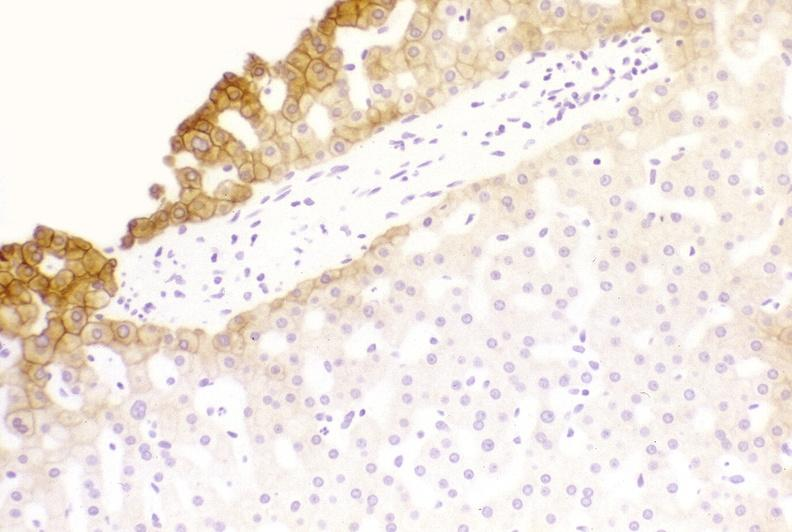does this image show low molecular weight keratin?
Answer the question using a single word or phrase. Yes 